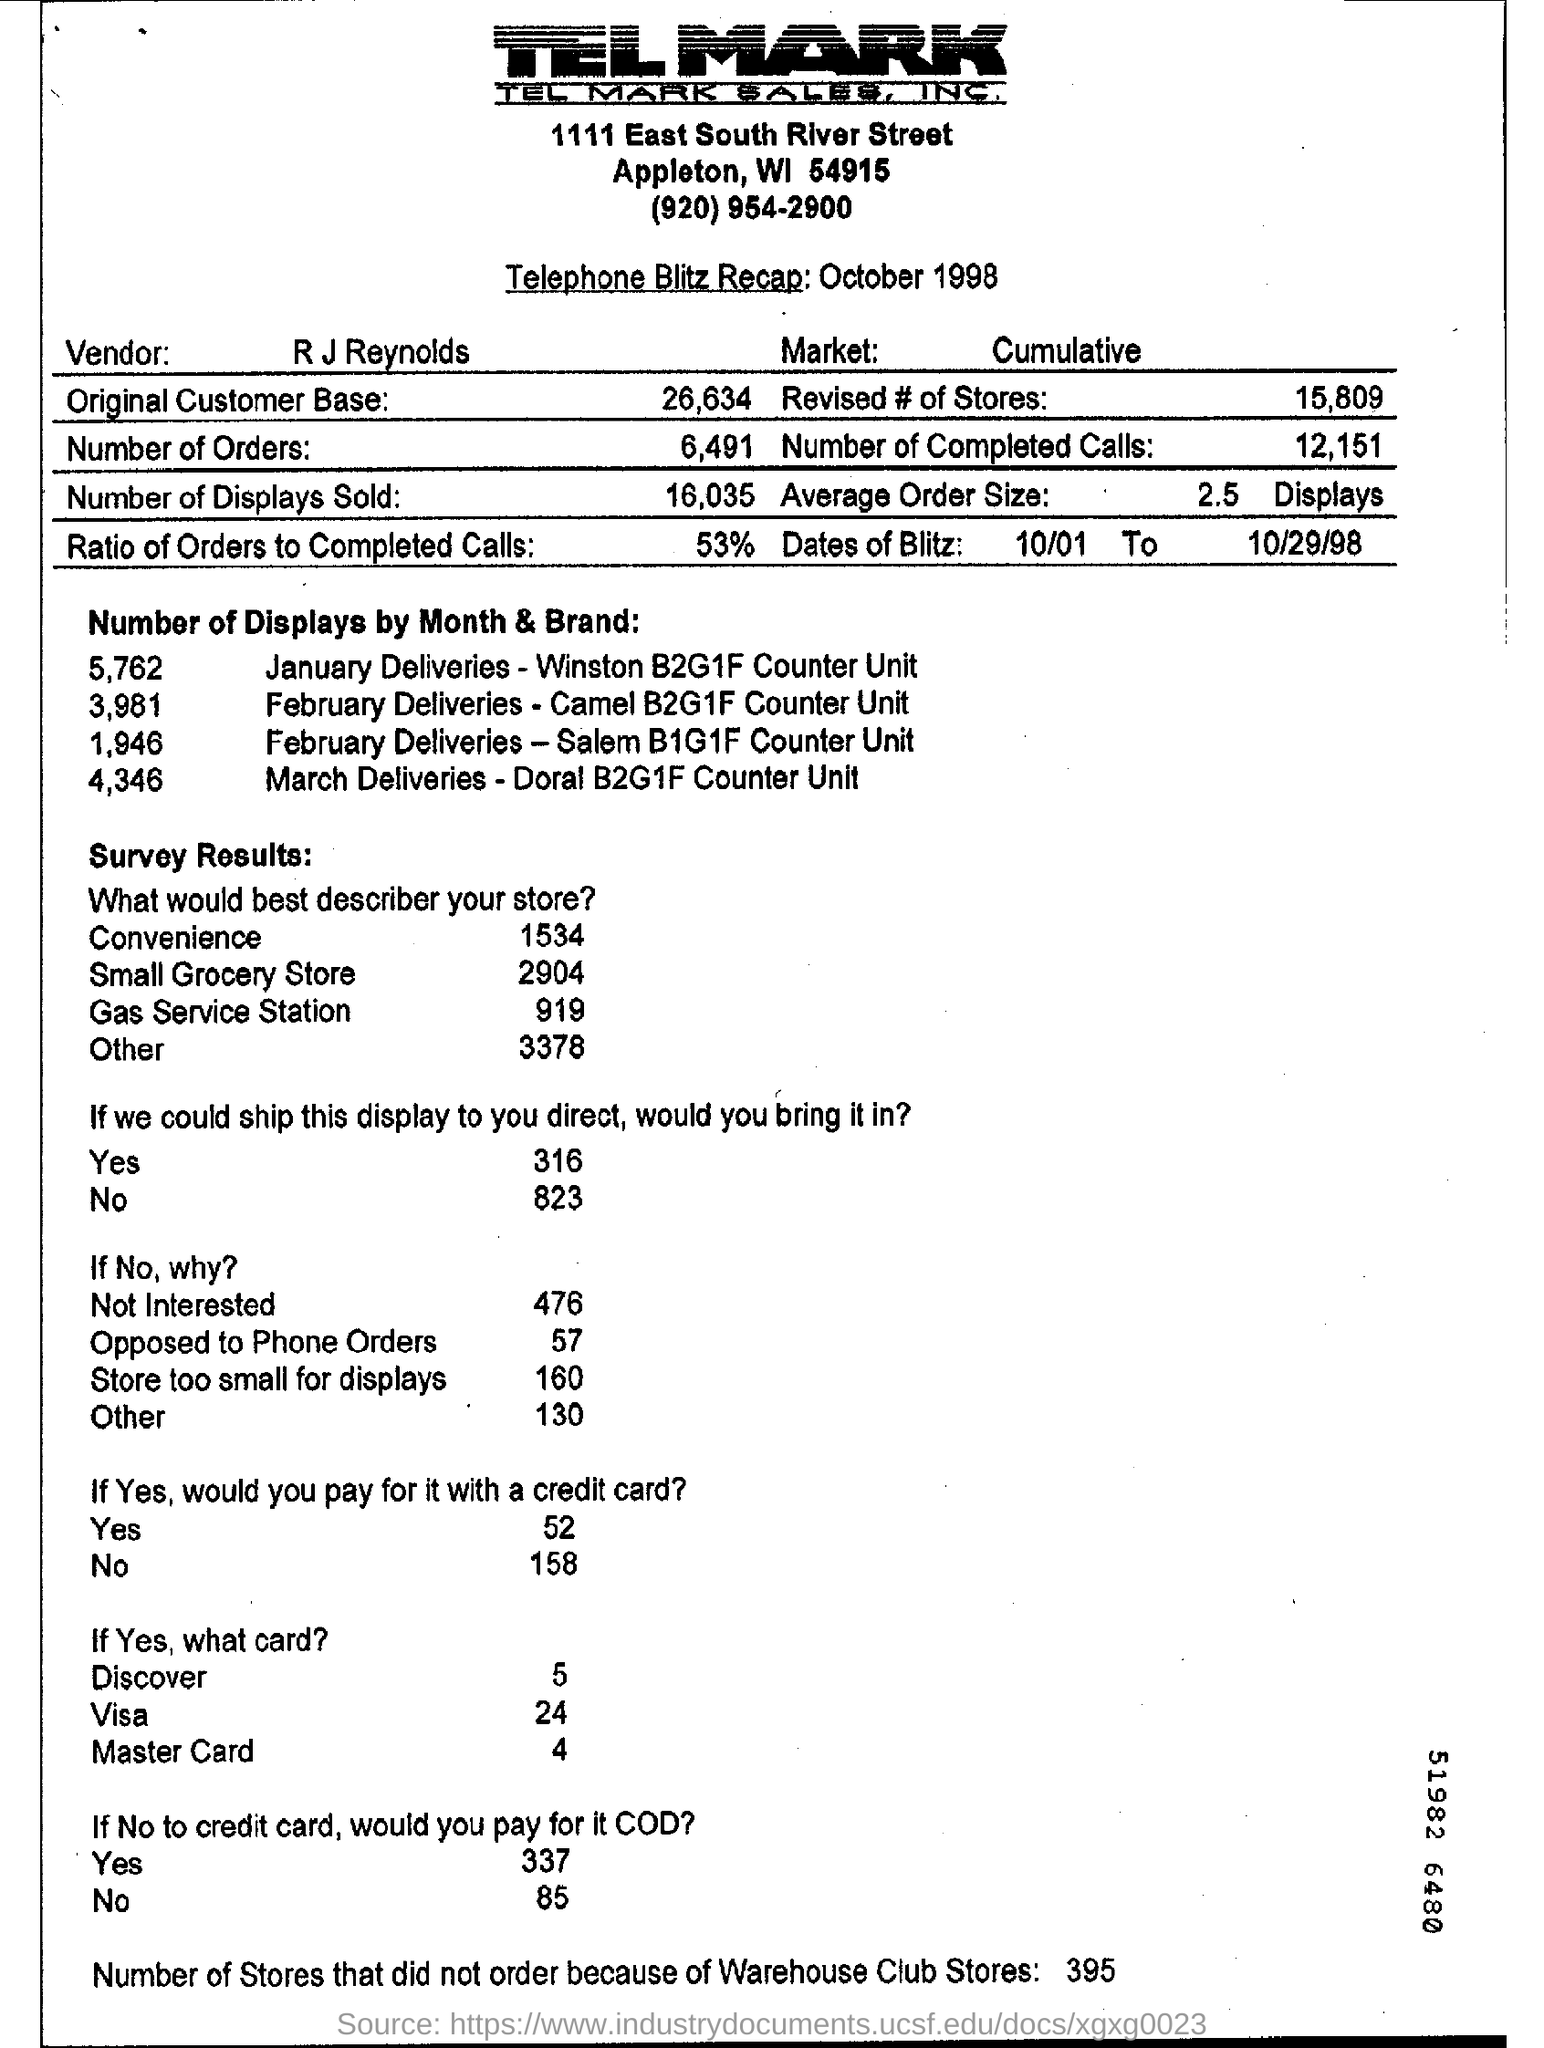How many number of displays sold?
Offer a terse response. 16,035. 